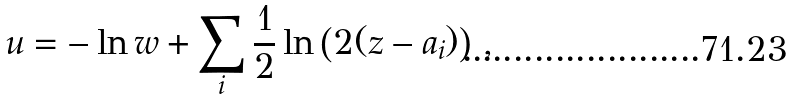<formula> <loc_0><loc_0><loc_500><loc_500>u = - \ln w + \sum _ { i } \frac { 1 } { 2 } \ln \left ( 2 ( z - a _ { i } ) \right ) \, ,</formula> 